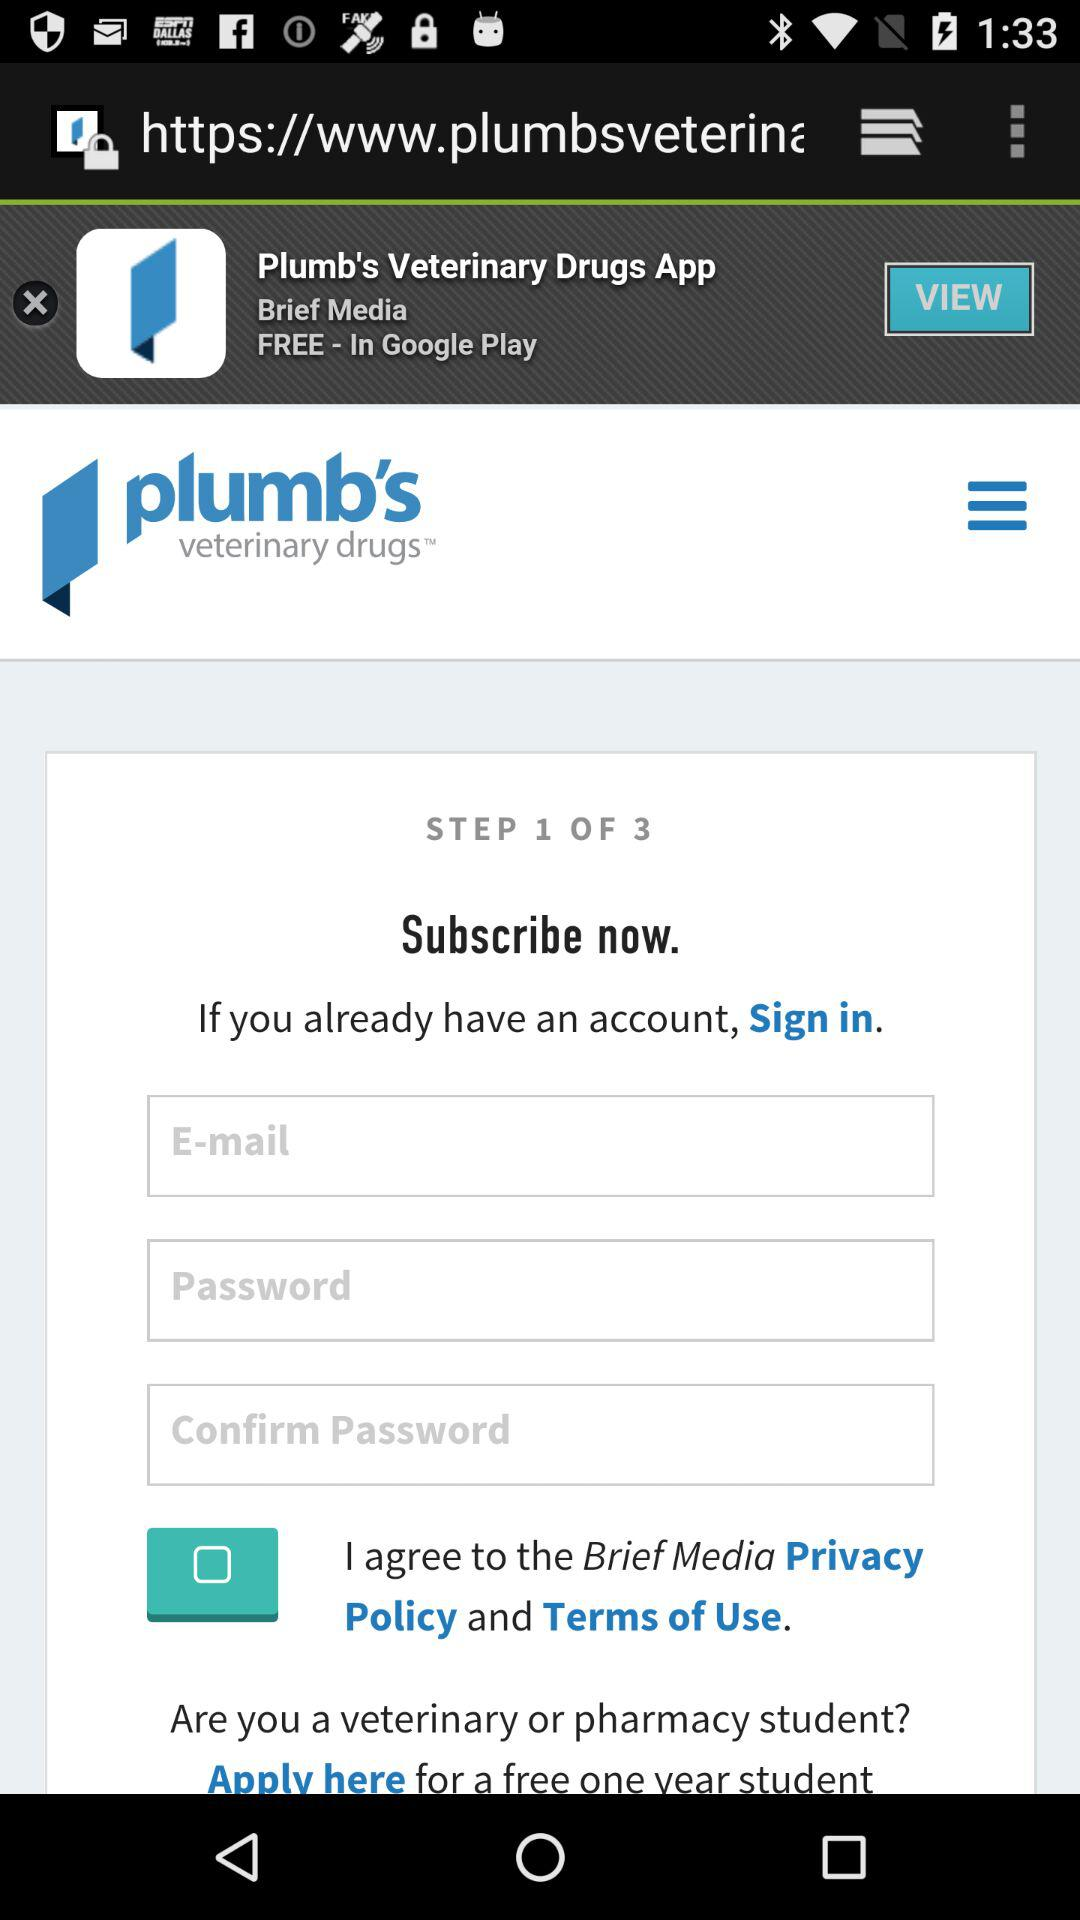At which step am I? You are at step 1. 